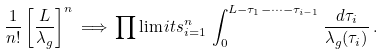Convert formula to latex. <formula><loc_0><loc_0><loc_500><loc_500>\frac { 1 } { n ! } \left [ \frac { L } { \lambda _ { g } } \right ] ^ { n } \, \Longrightarrow \, \prod \lim i t s _ { i = 1 } ^ { n } \, \int _ { 0 } ^ { L - \tau _ { 1 } - \cdots - \tau _ { i - 1 } } \frac { d \tau _ { i } } { \lambda _ { g } ( \tau _ { i } ) } \, .</formula> 